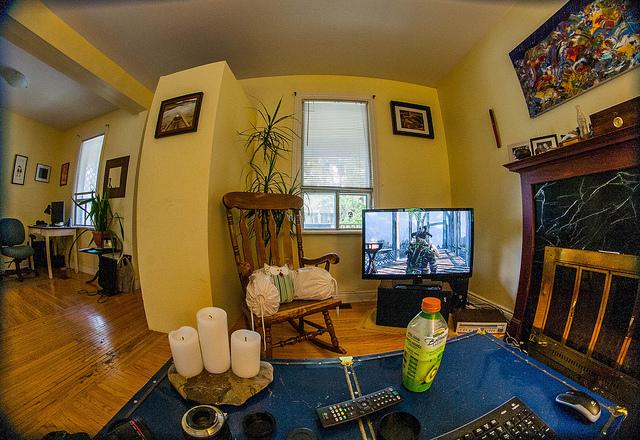Is this a store?
Write a very short answer. No. Is there any wood in the fireplace?
Be succinct. No. What pattern is on the tablecloth?
Keep it brief. None. What are the three like objects setting on  the table?
Write a very short answer. Candles. Is it quiet in this room?
Give a very brief answer. Yes. How many candles are there?
Short answer required. 3. How many windows do you see?
Write a very short answer. 2. Is there a picture on the TV?
Concise answer only. Yes. 